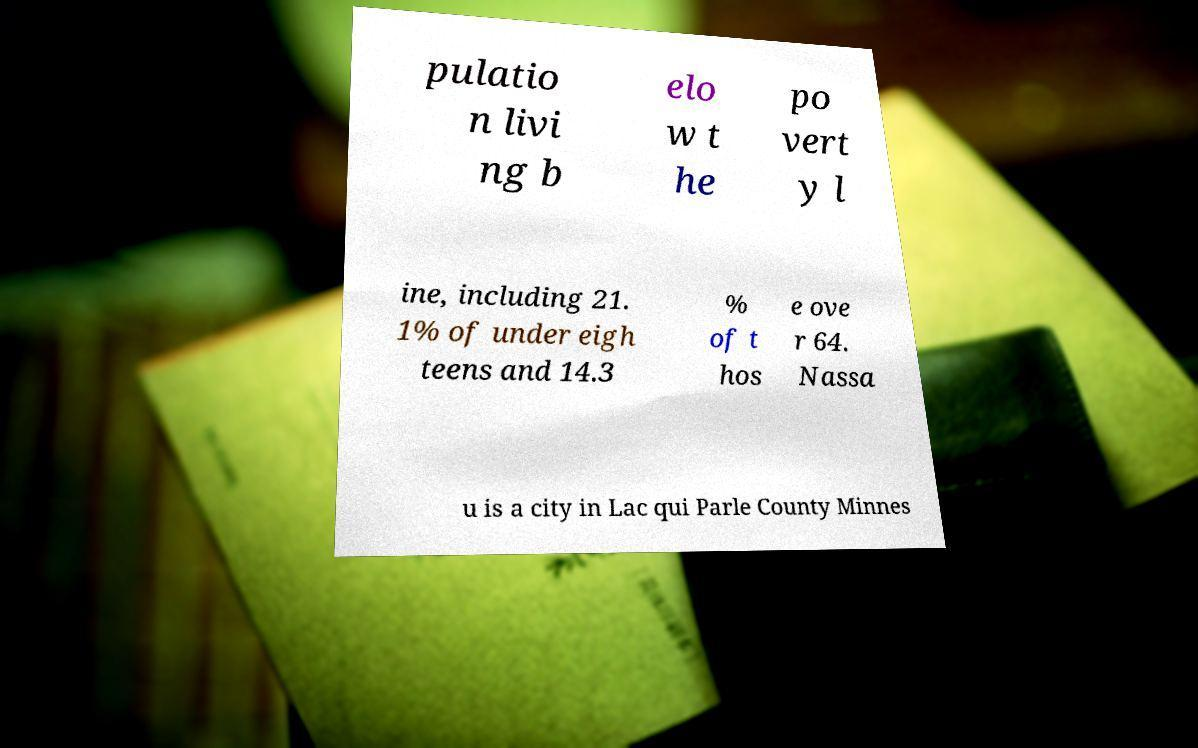Could you assist in decoding the text presented in this image and type it out clearly? pulatio n livi ng b elo w t he po vert y l ine, including 21. 1% of under eigh teens and 14.3 % of t hos e ove r 64. Nassa u is a city in Lac qui Parle County Minnes 